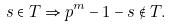Convert formula to latex. <formula><loc_0><loc_0><loc_500><loc_500>s \in T \Rightarrow p ^ { m } - 1 - s \notin T .</formula> 